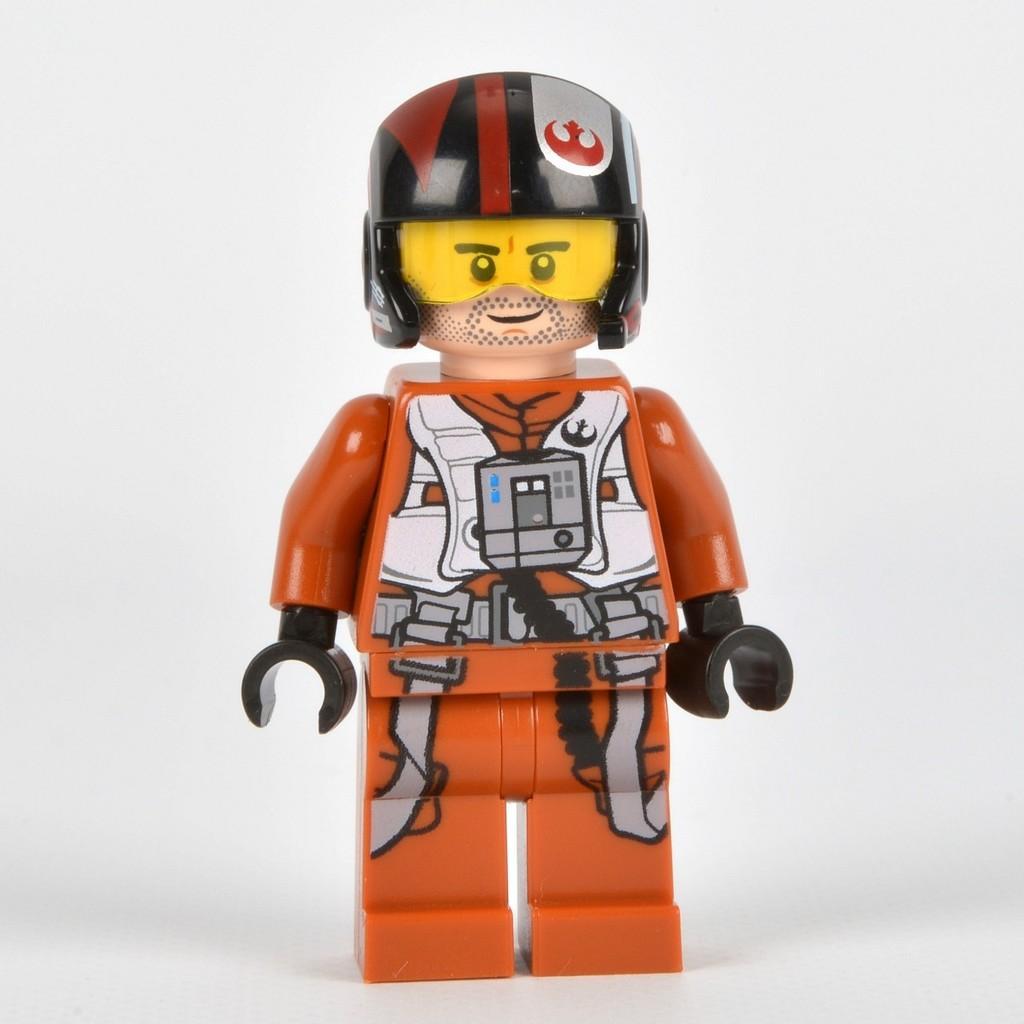Please provide a concise description of this image. There is a toy on a white surface. In the background it is white. 